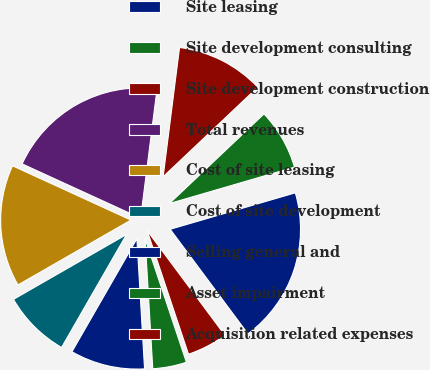Convert chart. <chart><loc_0><loc_0><loc_500><loc_500><pie_chart><fcel>Site leasing<fcel>Site development consulting<fcel>Site development construction<fcel>Total revenues<fcel>Cost of site leasing<fcel>Cost of site development<fcel>Selling general and<fcel>Asset impairment<fcel>Acquisition related expenses<nl><fcel>19.33%<fcel>7.56%<fcel>10.92%<fcel>20.17%<fcel>15.13%<fcel>8.4%<fcel>9.24%<fcel>4.2%<fcel>5.04%<nl></chart> 